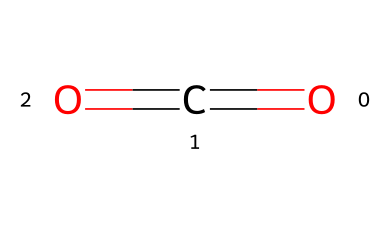What is the name of this chemical? The SMILES representation indicates a molecule consisting of one carbon atom and two oxygen atoms, which corresponds to the molecular structure of carbon dioxide.
Answer: carbon dioxide How many atoms are present in this molecule? In the provided SMILES structure, there are a total of three atoms: one carbon (C) atom and two oxygen (O) atoms.
Answer: three What type of bonding exists between the carbon and oxygen atoms in this molecule? Analyzing the SMILES representation, we see that there are double bonds between each of the oxygen atoms and the carbon atom, indicating that this molecule is held together by double covalent bonds.
Answer: double bonds What is the molecular geometry of carbon dioxide? Given the arrangement of the carbon and oxygen atoms in the structure (with two regions of electron density), the molecule adopts a linear geometry, specifically a linear shape.
Answer: linear How does carbon dioxide behave as a gas at room temperature? Carbon dioxide, represented by this structure, is a gas at room temperature due to its low molecular weight and the weak intermolecular forces present among the CO2 molecules, allowing them to move freely.
Answer: gas What role does carbon dioxide play in virtual lab simulations? In virtual lab simulations, carbon dioxide is often used as a model gas to study gas laws and chemical reactions because it is non-toxic, widely available, and easy to manipulate in various simulations.
Answer: model gas 